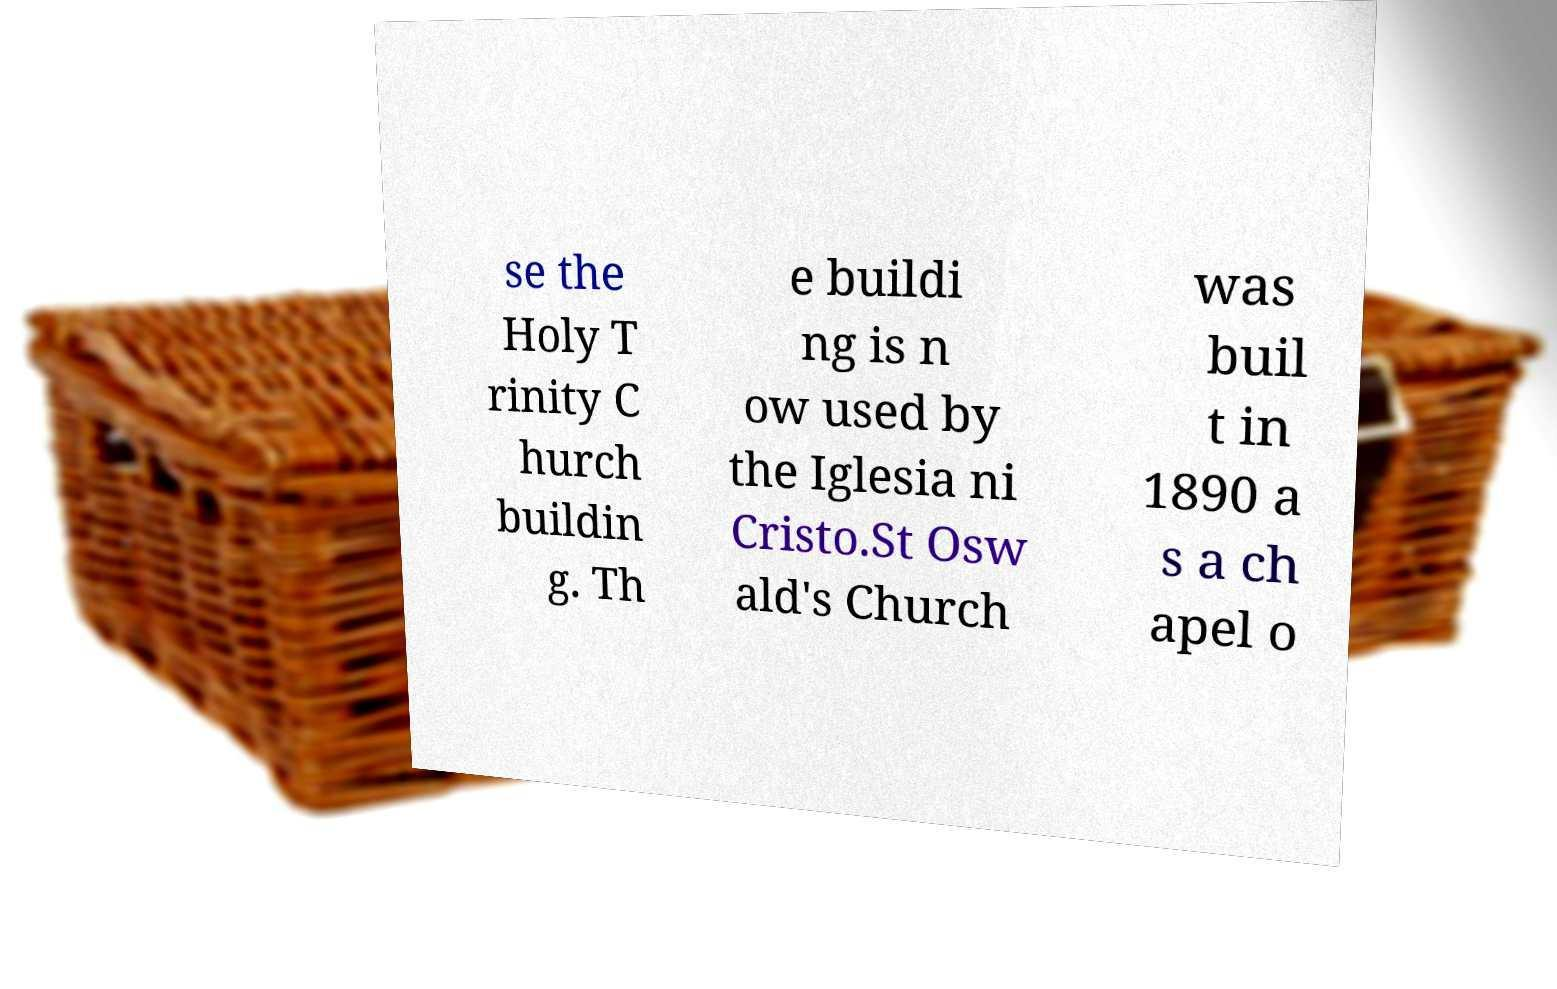Please identify and transcribe the text found in this image. se the Holy T rinity C hurch buildin g. Th e buildi ng is n ow used by the Iglesia ni Cristo.St Osw ald's Church was buil t in 1890 a s a ch apel o 